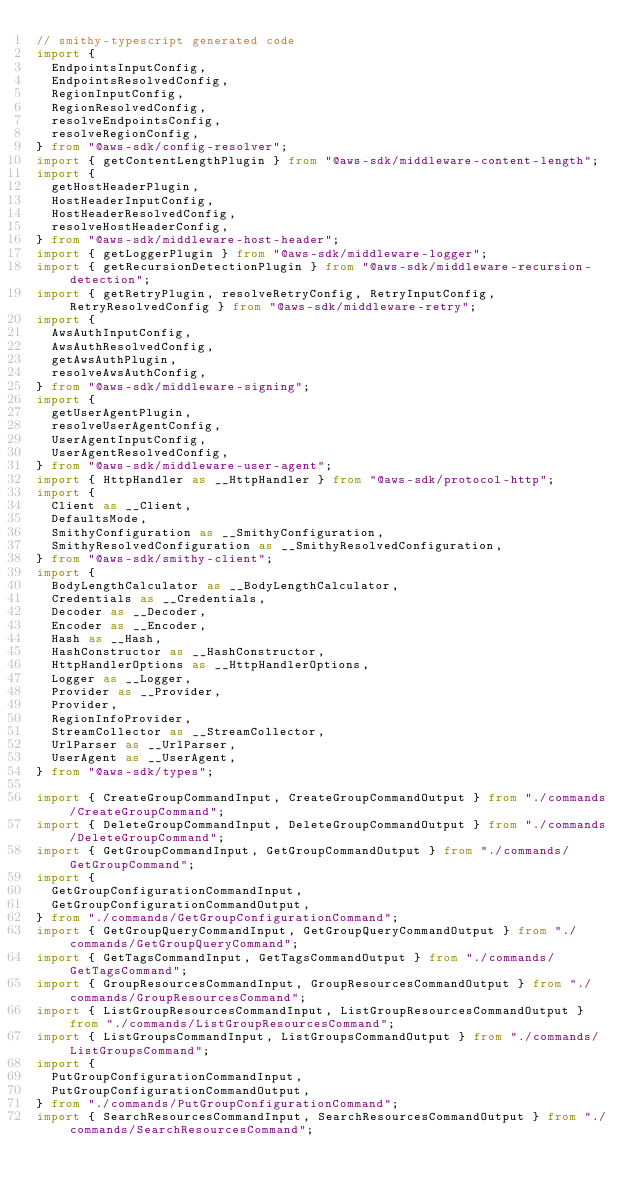<code> <loc_0><loc_0><loc_500><loc_500><_TypeScript_>// smithy-typescript generated code
import {
  EndpointsInputConfig,
  EndpointsResolvedConfig,
  RegionInputConfig,
  RegionResolvedConfig,
  resolveEndpointsConfig,
  resolveRegionConfig,
} from "@aws-sdk/config-resolver";
import { getContentLengthPlugin } from "@aws-sdk/middleware-content-length";
import {
  getHostHeaderPlugin,
  HostHeaderInputConfig,
  HostHeaderResolvedConfig,
  resolveHostHeaderConfig,
} from "@aws-sdk/middleware-host-header";
import { getLoggerPlugin } from "@aws-sdk/middleware-logger";
import { getRecursionDetectionPlugin } from "@aws-sdk/middleware-recursion-detection";
import { getRetryPlugin, resolveRetryConfig, RetryInputConfig, RetryResolvedConfig } from "@aws-sdk/middleware-retry";
import {
  AwsAuthInputConfig,
  AwsAuthResolvedConfig,
  getAwsAuthPlugin,
  resolveAwsAuthConfig,
} from "@aws-sdk/middleware-signing";
import {
  getUserAgentPlugin,
  resolveUserAgentConfig,
  UserAgentInputConfig,
  UserAgentResolvedConfig,
} from "@aws-sdk/middleware-user-agent";
import { HttpHandler as __HttpHandler } from "@aws-sdk/protocol-http";
import {
  Client as __Client,
  DefaultsMode,
  SmithyConfiguration as __SmithyConfiguration,
  SmithyResolvedConfiguration as __SmithyResolvedConfiguration,
} from "@aws-sdk/smithy-client";
import {
  BodyLengthCalculator as __BodyLengthCalculator,
  Credentials as __Credentials,
  Decoder as __Decoder,
  Encoder as __Encoder,
  Hash as __Hash,
  HashConstructor as __HashConstructor,
  HttpHandlerOptions as __HttpHandlerOptions,
  Logger as __Logger,
  Provider as __Provider,
  Provider,
  RegionInfoProvider,
  StreamCollector as __StreamCollector,
  UrlParser as __UrlParser,
  UserAgent as __UserAgent,
} from "@aws-sdk/types";

import { CreateGroupCommandInput, CreateGroupCommandOutput } from "./commands/CreateGroupCommand";
import { DeleteGroupCommandInput, DeleteGroupCommandOutput } from "./commands/DeleteGroupCommand";
import { GetGroupCommandInput, GetGroupCommandOutput } from "./commands/GetGroupCommand";
import {
  GetGroupConfigurationCommandInput,
  GetGroupConfigurationCommandOutput,
} from "./commands/GetGroupConfigurationCommand";
import { GetGroupQueryCommandInput, GetGroupQueryCommandOutput } from "./commands/GetGroupQueryCommand";
import { GetTagsCommandInput, GetTagsCommandOutput } from "./commands/GetTagsCommand";
import { GroupResourcesCommandInput, GroupResourcesCommandOutput } from "./commands/GroupResourcesCommand";
import { ListGroupResourcesCommandInput, ListGroupResourcesCommandOutput } from "./commands/ListGroupResourcesCommand";
import { ListGroupsCommandInput, ListGroupsCommandOutput } from "./commands/ListGroupsCommand";
import {
  PutGroupConfigurationCommandInput,
  PutGroupConfigurationCommandOutput,
} from "./commands/PutGroupConfigurationCommand";
import { SearchResourcesCommandInput, SearchResourcesCommandOutput } from "./commands/SearchResourcesCommand";</code> 